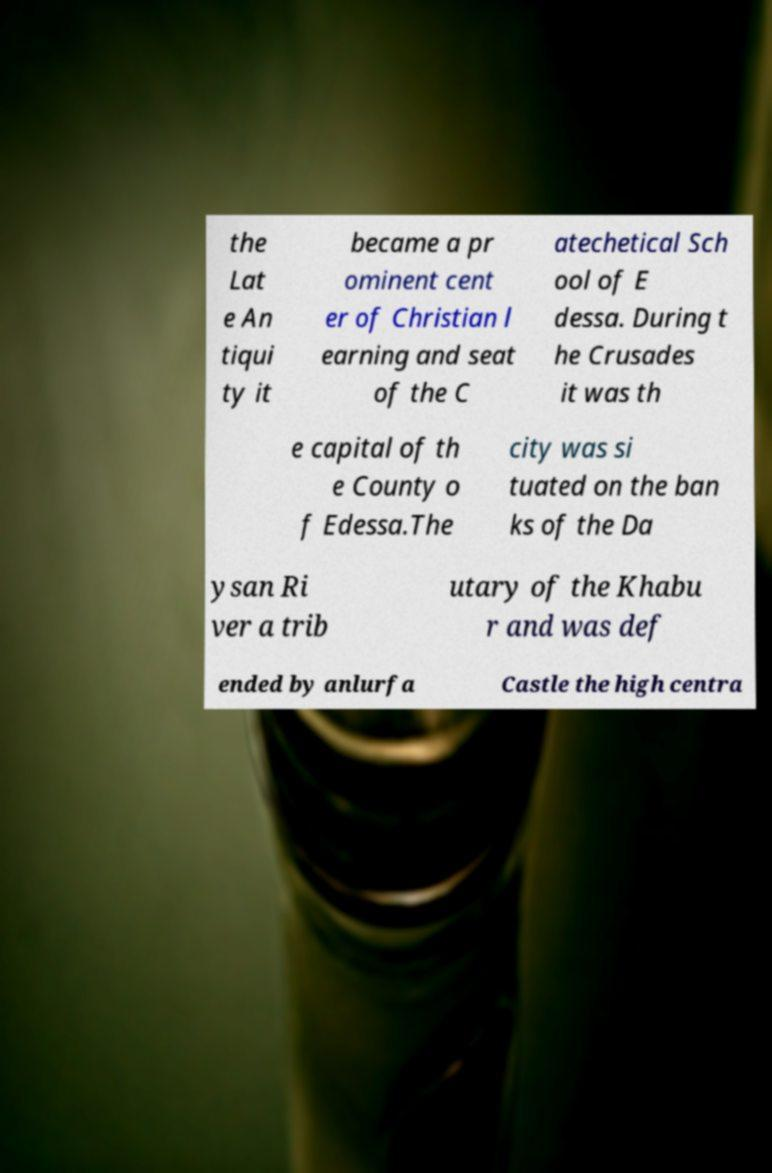I need the written content from this picture converted into text. Can you do that? the Lat e An tiqui ty it became a pr ominent cent er of Christian l earning and seat of the C atechetical Sch ool of E dessa. During t he Crusades it was th e capital of th e County o f Edessa.The city was si tuated on the ban ks of the Da ysan Ri ver a trib utary of the Khabu r and was def ended by anlurfa Castle the high centra 